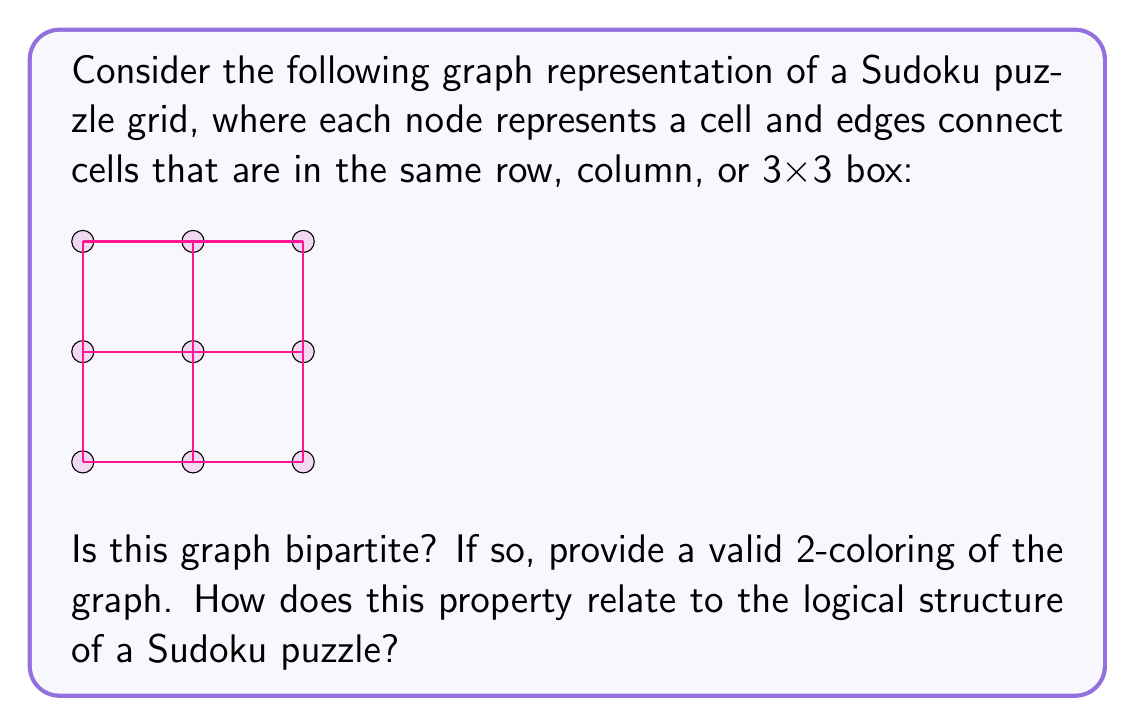Solve this math problem. To determine if the given graph is bipartite and find a valid 2-coloring, we can use a breadth-first search (BFS) approach:

1. Start with any node and assign it color 1.
2. For each uncolored neighbor of the current node, assign it the opposite color.
3. If we encounter a colored neighbor with the same color as the current node, the graph is not bipartite.
4. Repeat steps 2-3 for all nodes.

Let's apply this to our graph:

1. Start with the top-left node and assign it color 1.
2. Its neighbors (top-middle, top-right, middle-left, center) get color 2.
3. Continue this process for all nodes.

We find that we can consistently assign colors without conflicts:

[asy]
unitsize(0.5cm);
pair[] nodes = {(0,0), (2,0), (4,0), (0,2), (2,2), (4,2), (0,4), (2,4), (4,4)};
for(int i = 0; i < 9; ++i) {
    if(i % 2 == 0) {
        fill(nodes[i], red);
    } else {
        fill(nodes[i], blue);
    }
    dot(nodes[i]);
}
for(int i = 0; i < 9; ++i) {
    for(int j = i+1; j < 9; ++j) {
        if(i%3 == j%3 || i/3 == j/3 || (i%3 == j%3 && i/3 == j/3)) {
            draw(nodes[i]--nodes[j]);
        }
    }
}
[/asy]

The graph is indeed bipartite, with a valid 2-coloring as shown (red and blue).

This property relates to the logical structure of a Sudoku puzzle in the following way:

1. In a Sudoku puzzle, each cell can only contain one number.
2. The bipartite property ensures that no two adjacent cells (in the same row, column, or 3x3 box) have the same color.
3. This corresponds to the Sudoku rule that no two cells in the same row, column, or 3x3 box can contain the same number.

The 2-coloring of this graph represents a fundamental constraint in Sudoku puzzles, highlighting the logical nature of the game. It demonstrates that the puzzle's structure inherently prevents conflicts between adjacent cells, which is crucial for maintaining the puzzle's logical consistency.
Answer: Yes, the graph is bipartite. A valid 2-coloring can be achieved by alternating colors for each node, as shown in the explanation. This bipartite property reflects the logical structure of a Sudoku puzzle, where no two cells in the same row, column, or 3x3 box can contain the same number, mirroring the constraint that no two adjacent nodes in the graph can have the same color. 